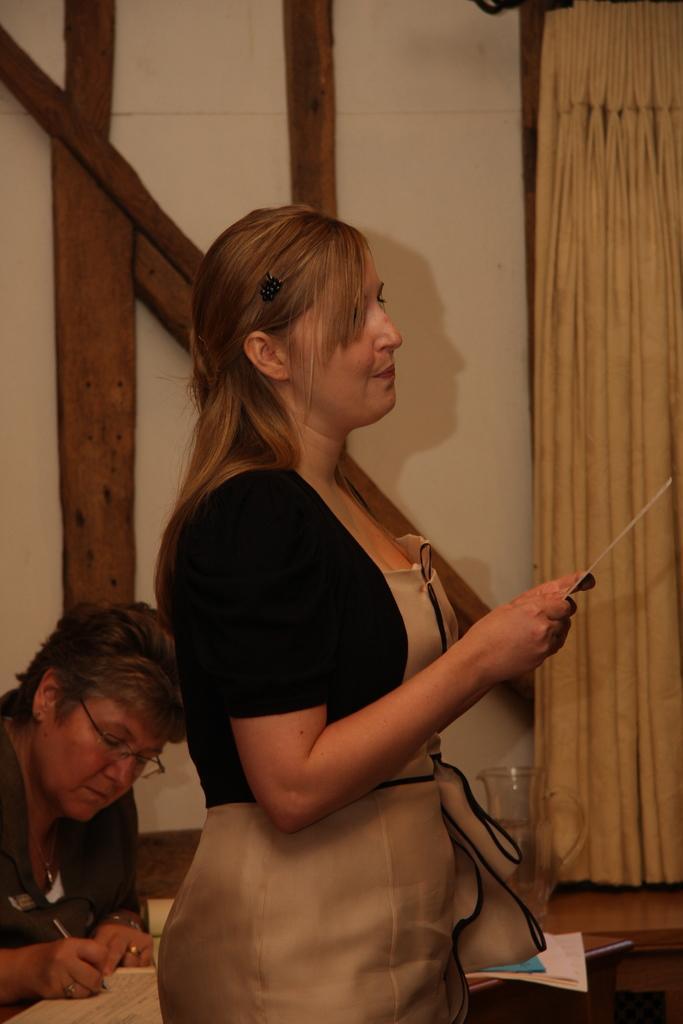Please provide a concise description of this image. This picture is taken inside the room. In this image, in the middle, we can see a woman standing and holding some object in her hand. On the left side, we can also see another woman sitting in front of the table, on the table, we can see some books. In the background, we can see a curtain, wall and wooden poles. 